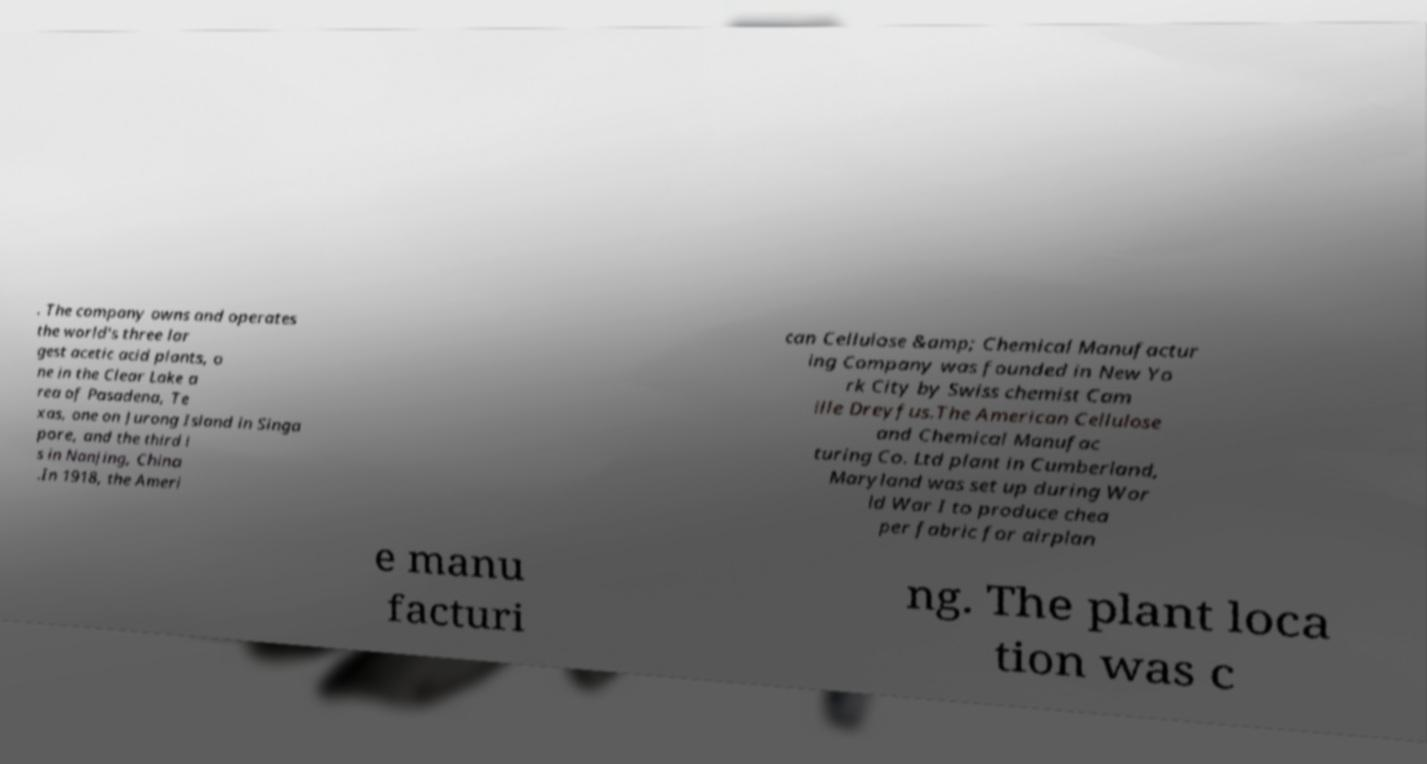For documentation purposes, I need the text within this image transcribed. Could you provide that? . The company owns and operates the world's three lar gest acetic acid plants, o ne in the Clear Lake a rea of Pasadena, Te xas, one on Jurong Island in Singa pore, and the third i s in Nanjing, China .In 1918, the Ameri can Cellulose &amp; Chemical Manufactur ing Company was founded in New Yo rk City by Swiss chemist Cam ille Dreyfus.The American Cellulose and Chemical Manufac turing Co. Ltd plant in Cumberland, Maryland was set up during Wor ld War I to produce chea per fabric for airplan e manu facturi ng. The plant loca tion was c 